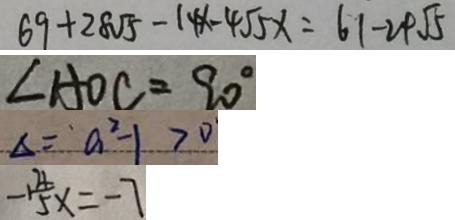<formula> <loc_0><loc_0><loc_500><loc_500>6 9 + 2 8 \sqrt { 5 } - 1 4 x - 4 \sqrt { 5 } x = 6 1 - 2 4 \sqrt { 5 } 
 \angle A O C = 9 0 ^ { \circ } 
 \Delta = a ^ { 2 } - 1 > 0 
 - 1 \frac { 4 } { 5 } x = - 7</formula> 